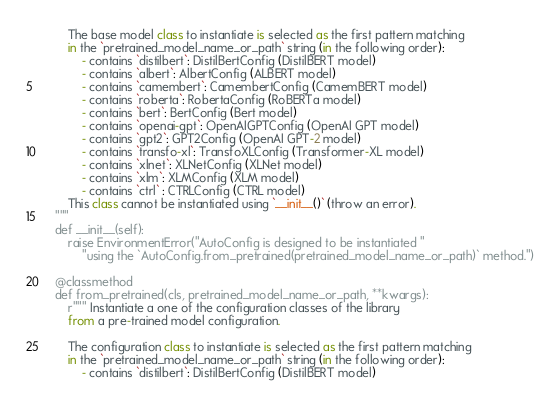Convert code to text. <code><loc_0><loc_0><loc_500><loc_500><_Python_>        The base model class to instantiate is selected as the first pattern matching
        in the `pretrained_model_name_or_path` string (in the following order):
            - contains `distilbert`: DistilBertConfig (DistilBERT model)
            - contains `albert`: AlbertConfig (ALBERT model)
            - contains `camembert`: CamembertConfig (CamemBERT model)
            - contains `roberta`: RobertaConfig (RoBERTa model)
            - contains `bert`: BertConfig (Bert model)
            - contains `openai-gpt`: OpenAIGPTConfig (OpenAI GPT model)
            - contains `gpt2`: GPT2Config (OpenAI GPT-2 model)
            - contains `transfo-xl`: TransfoXLConfig (Transformer-XL model)
            - contains `xlnet`: XLNetConfig (XLNet model)
            - contains `xlm`: XLMConfig (XLM model)
            - contains `ctrl` : CTRLConfig (CTRL model)
        This class cannot be instantiated using `__init__()` (throw an error).
    """
    def __init__(self):
        raise EnvironmentError("AutoConfig is designed to be instantiated "
            "using the `AutoConfig.from_pretrained(pretrained_model_name_or_path)` method.")

    @classmethod
    def from_pretrained(cls, pretrained_model_name_or_path, **kwargs):
        r""" Instantiate a one of the configuration classes of the library
        from a pre-trained model configuration.

        The configuration class to instantiate is selected as the first pattern matching
        in the `pretrained_model_name_or_path` string (in the following order):
            - contains `distilbert`: DistilBertConfig (DistilBERT model)</code> 